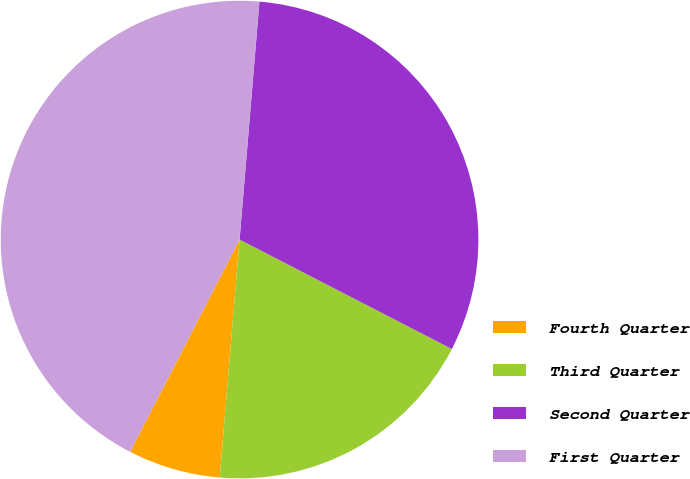Convert chart to OTSL. <chart><loc_0><loc_0><loc_500><loc_500><pie_chart><fcel>Fourth Quarter<fcel>Third Quarter<fcel>Second Quarter<fcel>First Quarter<nl><fcel>6.25%<fcel>18.75%<fcel>31.25%<fcel>43.75%<nl></chart> 